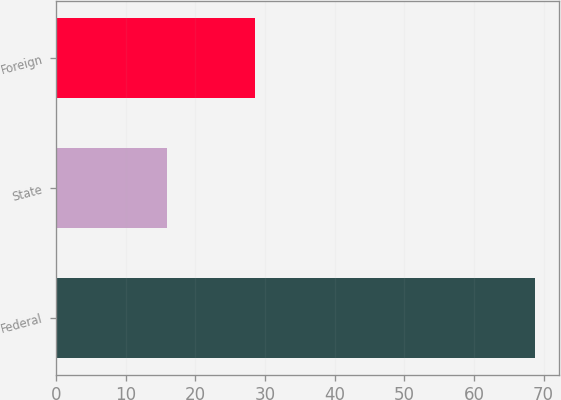Convert chart. <chart><loc_0><loc_0><loc_500><loc_500><bar_chart><fcel>Federal<fcel>State<fcel>Foreign<nl><fcel>68.8<fcel>15.9<fcel>28.6<nl></chart> 